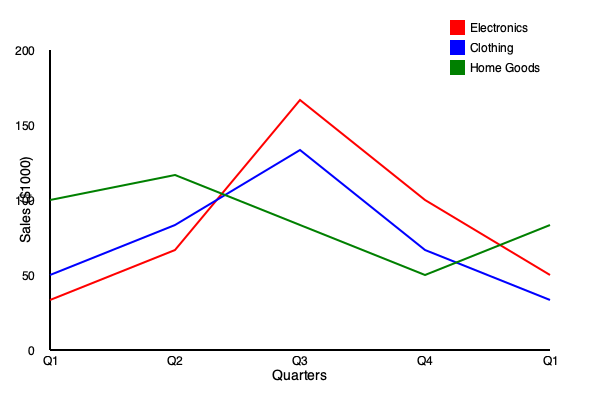Based on the seasonal sales trends shown in the line graph, which product category exhibits the most significant fluctuation between Q3 and Q4, and what is the approximate percentage change in sales for this category? To answer this question, we need to follow these steps:

1. Identify the lines representing each product category:
   - Red line: Electronics
   - Blue line: Clothing
   - Green line: Home Goods

2. Focus on the changes between Q3 (third data point) and Q4 (fourth data point) for each category.

3. Calculate the approximate percentage change for each category:

   a) Electronics:
      Q3 sales: ~$150,000
      Q4 sales: ~$100,000
      Percentage change = $(100,000 - 150,000) / 150,000 * 100\% = -33.33\%$

   b) Clothing:
      Q3 sales: ~$125,000
      Q4 sales: ~$75,000
      Percentage change = $(75,000 - 125,000) / 125,000 * 100\% = -40\%$

   c) Home Goods:
      Q3 sales: ~$87,500
      Q4 sales: ~$62,500
      Percentage change = $(62,500 - 87,500) / 87,500 * 100\% = -28.57\%$

4. Compare the percentage changes to determine which category has the most significant fluctuation:
   Electronics: -33.33%
   Clothing: -40%
   Home Goods: -28.57%

The category with the largest absolute percentage change is Clothing, with a 40% decrease in sales from Q3 to Q4.
Answer: Clothing, -40% 